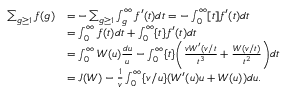Convert formula to latex. <formula><loc_0><loc_0><loc_500><loc_500>\begin{array} { r l } { \sum _ { g \geq 1 } f ( g ) } & { = - \sum _ { g \geq 1 } \int _ { g } ^ { \infty } f ^ { \prime } ( t ) d t = - \int _ { 0 } ^ { \infty } [ t ] f ^ { \prime } ( t ) d t } \\ & { = \int _ { 0 } ^ { \infty } f ( t ) d t + \int _ { 0 } ^ { \infty } \{ t \} f ^ { \prime } ( t ) d t } \\ & { = \int _ { 0 } ^ { \infty } W ( u ) \frac { d u } { u } - \int _ { 0 } ^ { \infty } \{ t \} \left ( \frac { v W ^ { \prime } ( v / t } { t ^ { 3 } } + \frac { W ( v / t ) } { t ^ { 2 } } \right ) d t } \\ & { = J ( W ) - \frac { 1 } { v } \int _ { 0 } ^ { \infty } \{ v / u \} ( W ^ { \prime } ( u ) u + W ( u ) ) d u . } \end{array}</formula> 